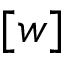Convert formula to latex. <formula><loc_0><loc_0><loc_500><loc_500>[ w ]</formula> 